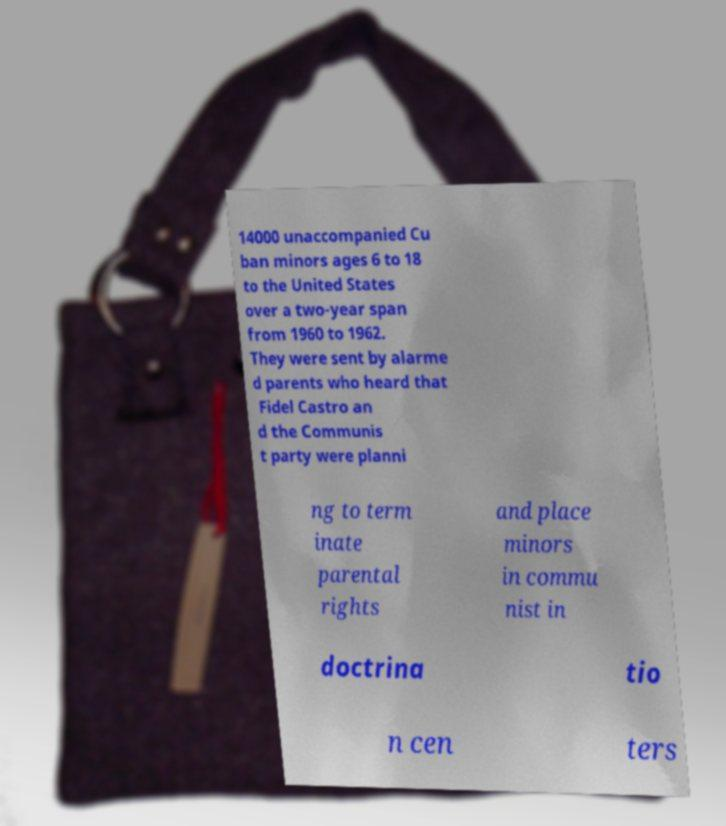Could you assist in decoding the text presented in this image and type it out clearly? 14000 unaccompanied Cu ban minors ages 6 to 18 to the United States over a two-year span from 1960 to 1962. They were sent by alarme d parents who heard that Fidel Castro an d the Communis t party were planni ng to term inate parental rights and place minors in commu nist in doctrina tio n cen ters 